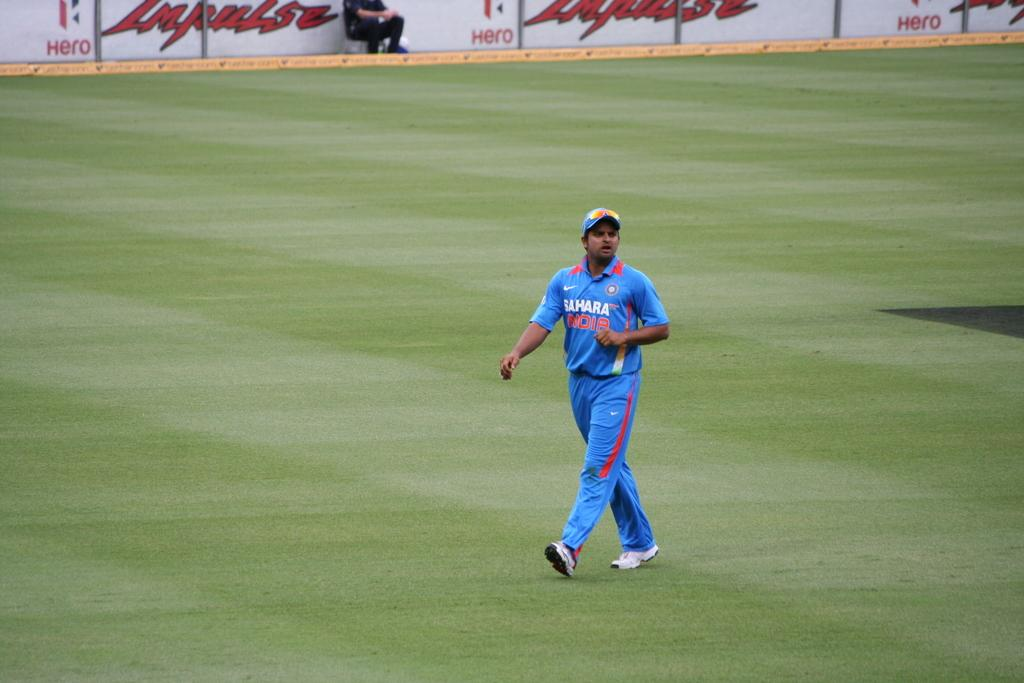<image>
Relay a brief, clear account of the picture shown. An athlete wearing a blue Sahara uniform is walking across a green field. 